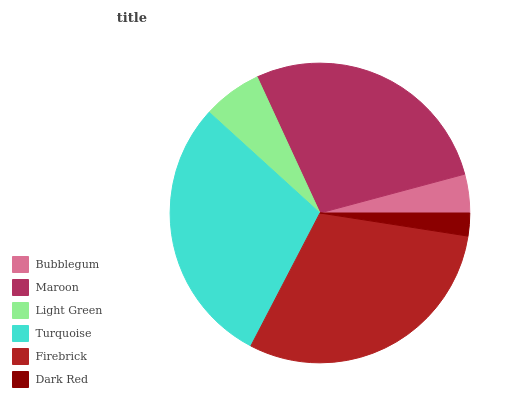Is Dark Red the minimum?
Answer yes or no. Yes. Is Firebrick the maximum?
Answer yes or no. Yes. Is Maroon the minimum?
Answer yes or no. No. Is Maroon the maximum?
Answer yes or no. No. Is Maroon greater than Bubblegum?
Answer yes or no. Yes. Is Bubblegum less than Maroon?
Answer yes or no. Yes. Is Bubblegum greater than Maroon?
Answer yes or no. No. Is Maroon less than Bubblegum?
Answer yes or no. No. Is Maroon the high median?
Answer yes or no. Yes. Is Light Green the low median?
Answer yes or no. Yes. Is Dark Red the high median?
Answer yes or no. No. Is Firebrick the low median?
Answer yes or no. No. 